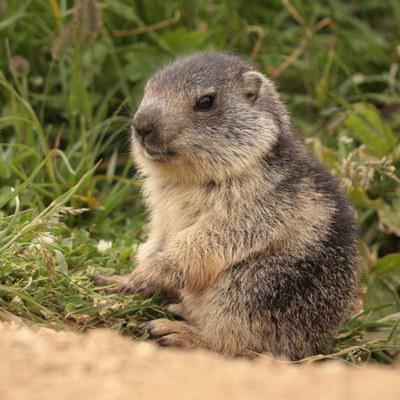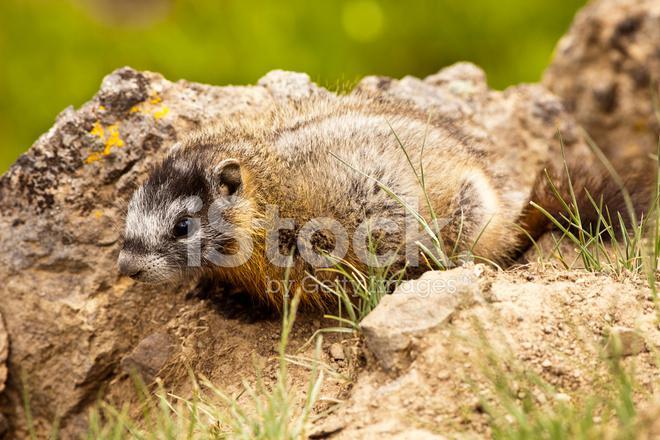The first image is the image on the left, the second image is the image on the right. Examine the images to the left and right. Is the description "There is at least two rodents in the right image." accurate? Answer yes or no. No. The first image is the image on the left, the second image is the image on the right. For the images shown, is this caption "The left and right image contains the same number of prairie dogs." true? Answer yes or no. Yes. 